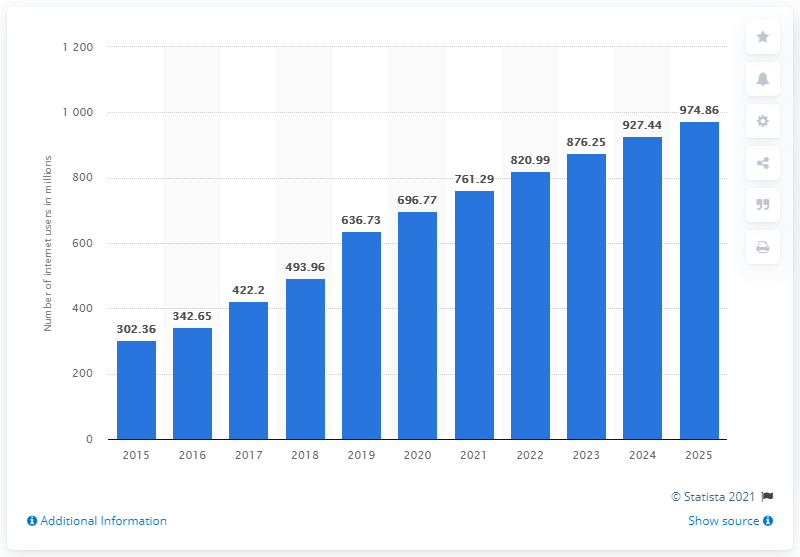Mention a couple of crucial points in this snapshot. As of 2020, India had approximately 696.77 million internet users. As of 2020, India had 974,863,000 internet users. 